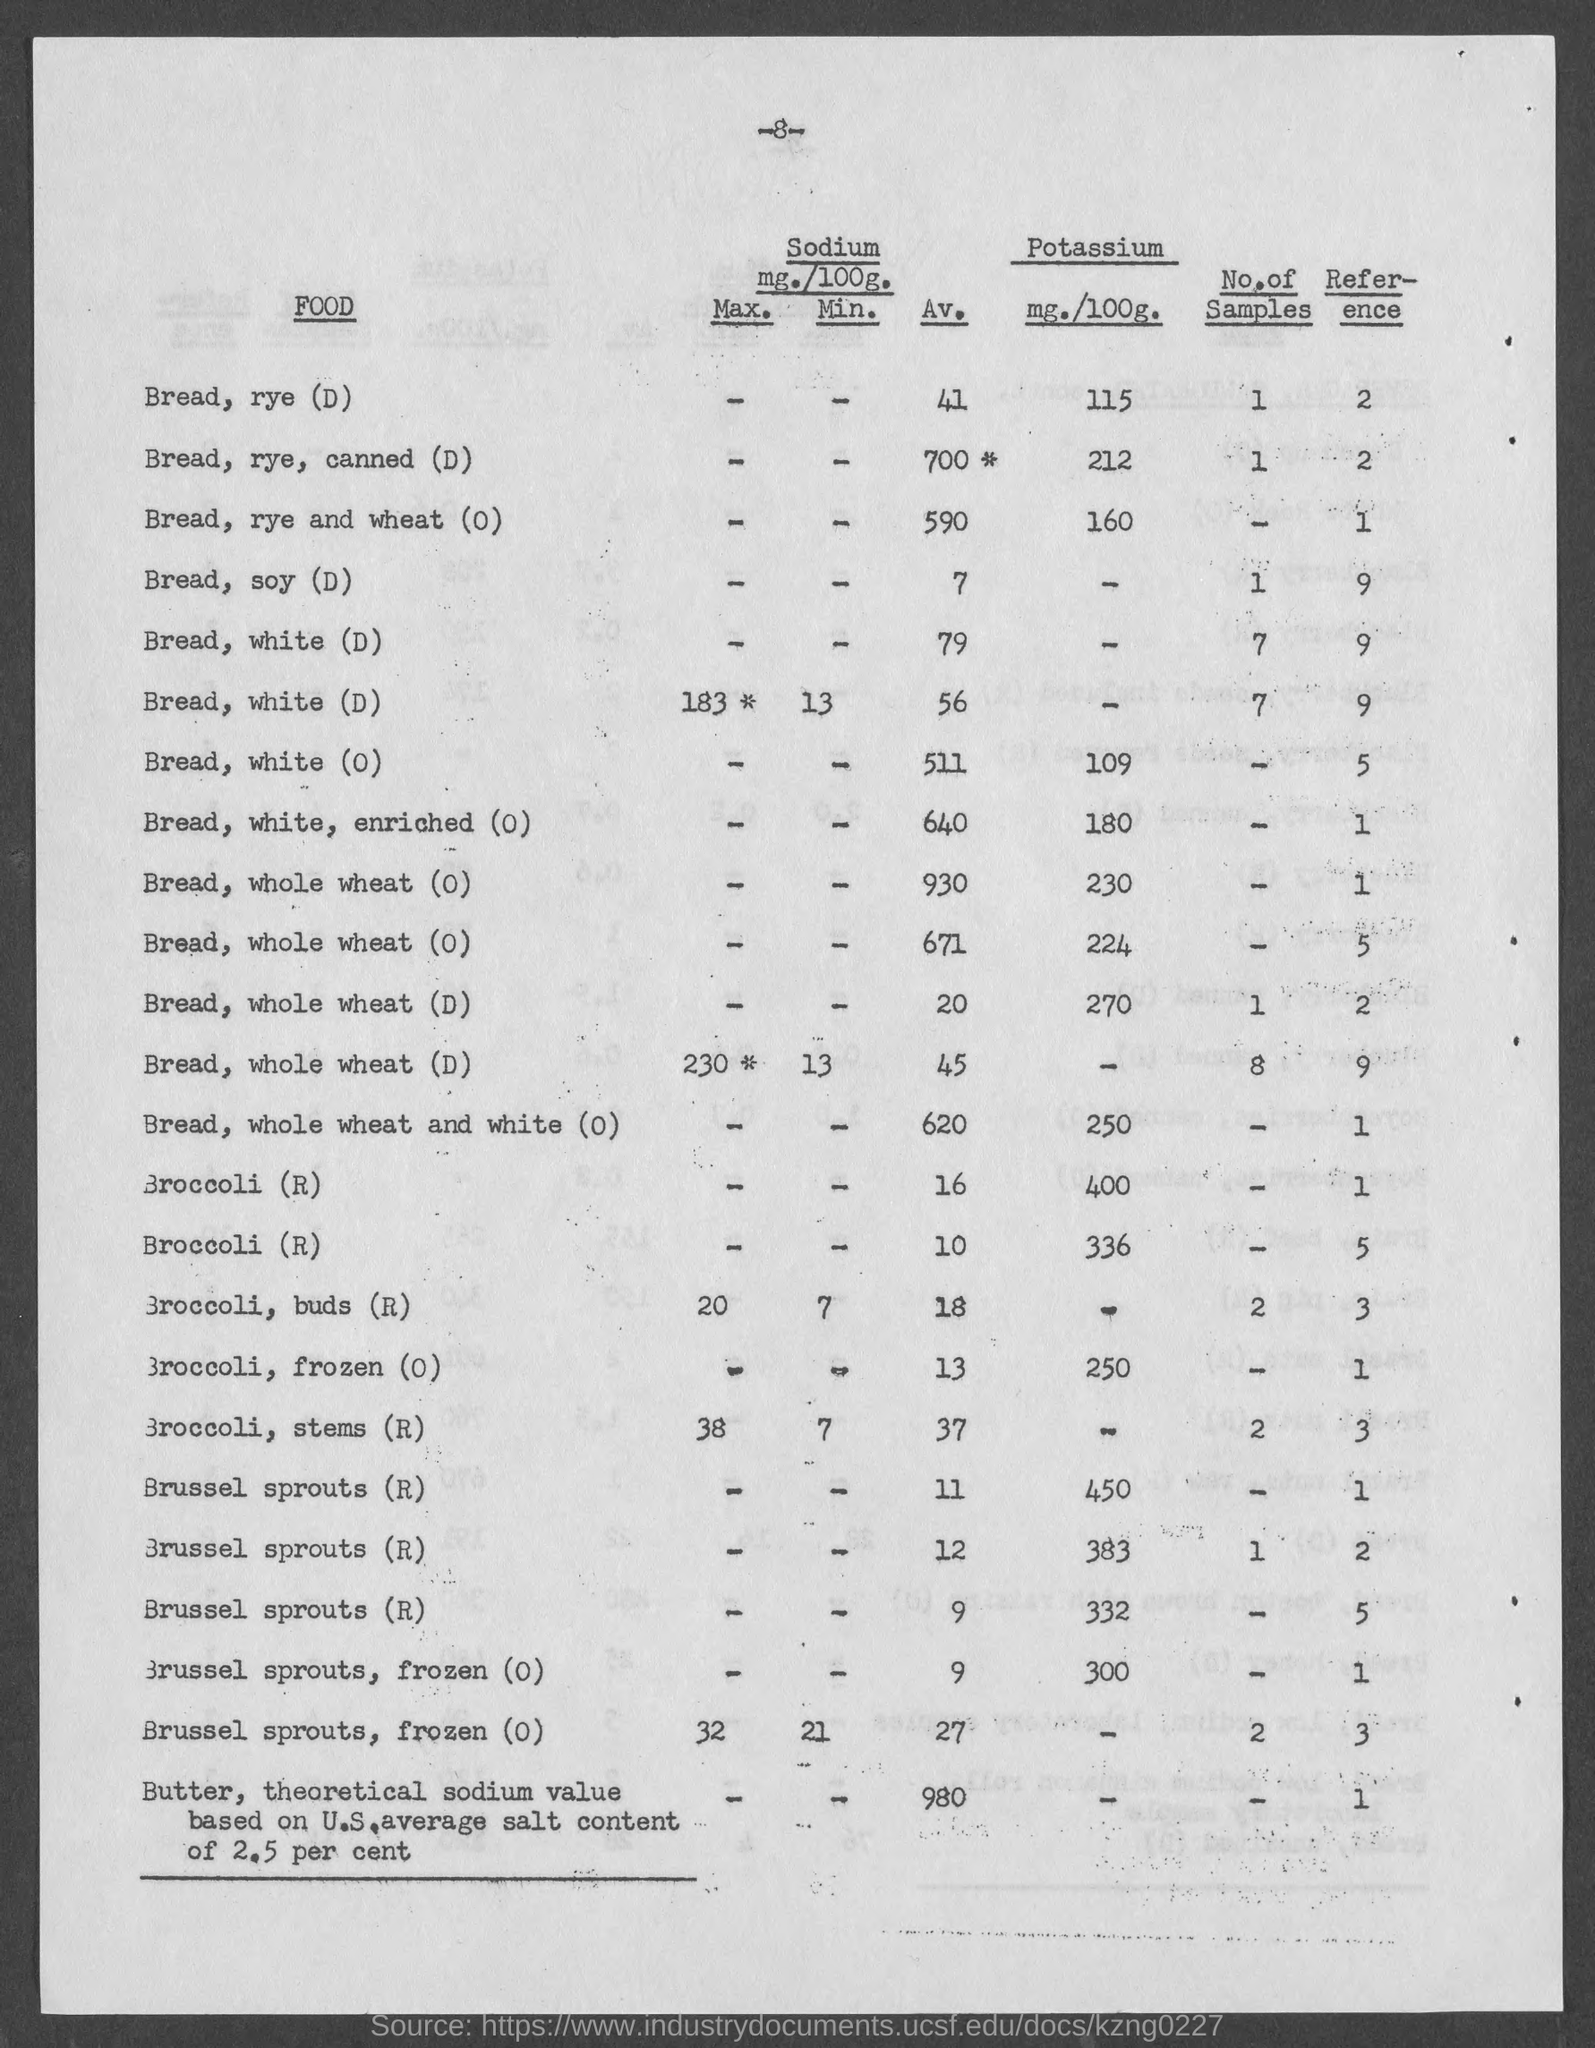What is the Av. Sodium in Bread, rye (D)?
Offer a terse response. 41. What is the Av. Sodium in Bread, rye, canned (D)?
Give a very brief answer. 700 *. What is the Av. Sodium in Bread, rye and wheat(0)?
Keep it short and to the point. 590. What is the Av. Sodium in Bread, soy (D)?
Your answer should be very brief. 7. What is the Av. Sodium in Bread, white (D)?
Offer a very short reply. 79. What is the Av. Sodium in Bread, white, enriched (0)?
Provide a succinct answer. 640. What is the Av. Sodium in Broccoli, buds (R)?
Give a very brief answer. 18. What is the Av. Sodium in Broccoli, frozen (0)?
Provide a succinct answer. 13. What is the Av. Sodium in Broccoli, stems (R)?
Offer a very short reply. 37. What is the Potassium in Broccoli, frozen (0)?
Make the answer very short. 250. 